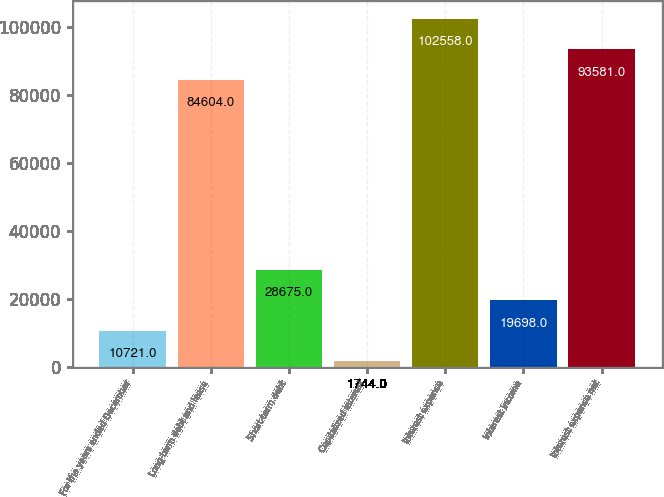<chart> <loc_0><loc_0><loc_500><loc_500><bar_chart><fcel>For the years ended December<fcel>Long-term debt and lease<fcel>Short-term debt<fcel>Capitalized interest<fcel>Interest expense<fcel>Interest income<fcel>Interest expense net<nl><fcel>10721<fcel>84604<fcel>28675<fcel>1744<fcel>102558<fcel>19698<fcel>93581<nl></chart> 